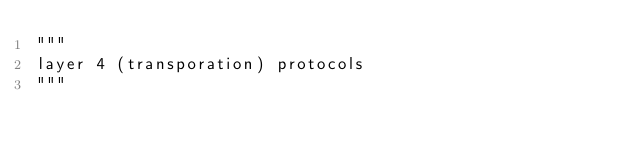Convert code to text. <code><loc_0><loc_0><loc_500><loc_500><_Python_>"""
layer 4 (transporation) protocols
"""

</code> 